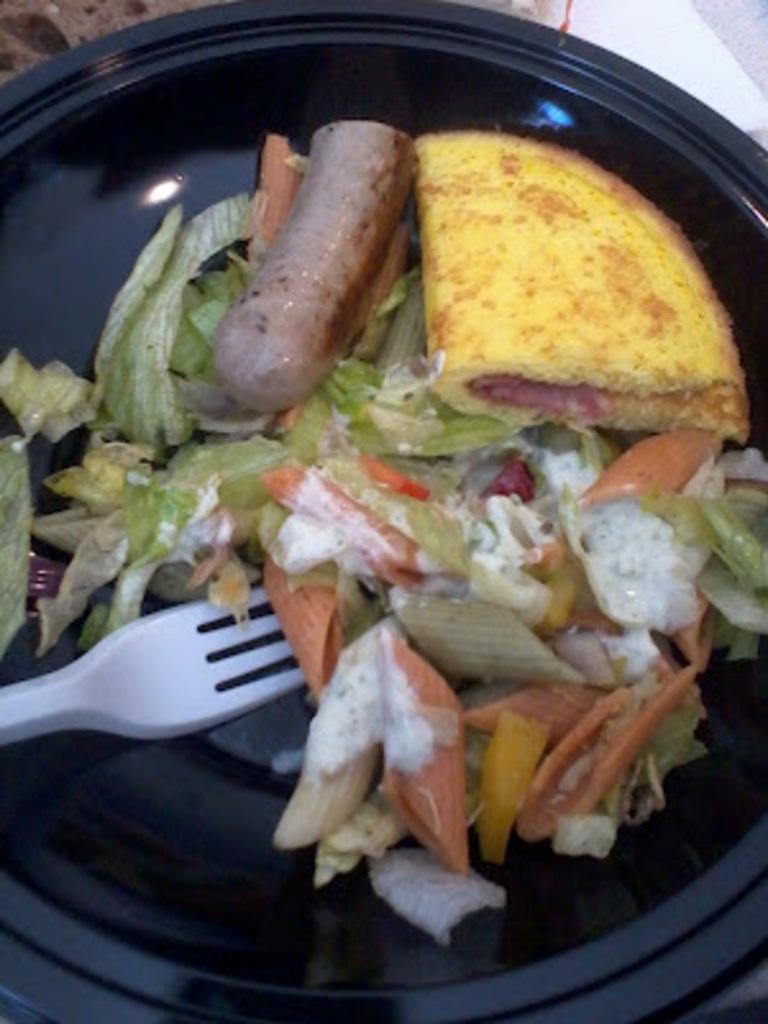Can you describe this image briefly? In this image we can see a plate filled with food item and we can also see a fork. 